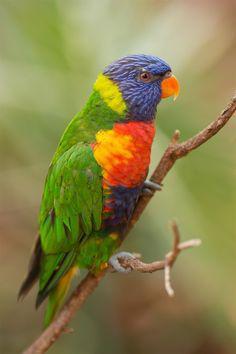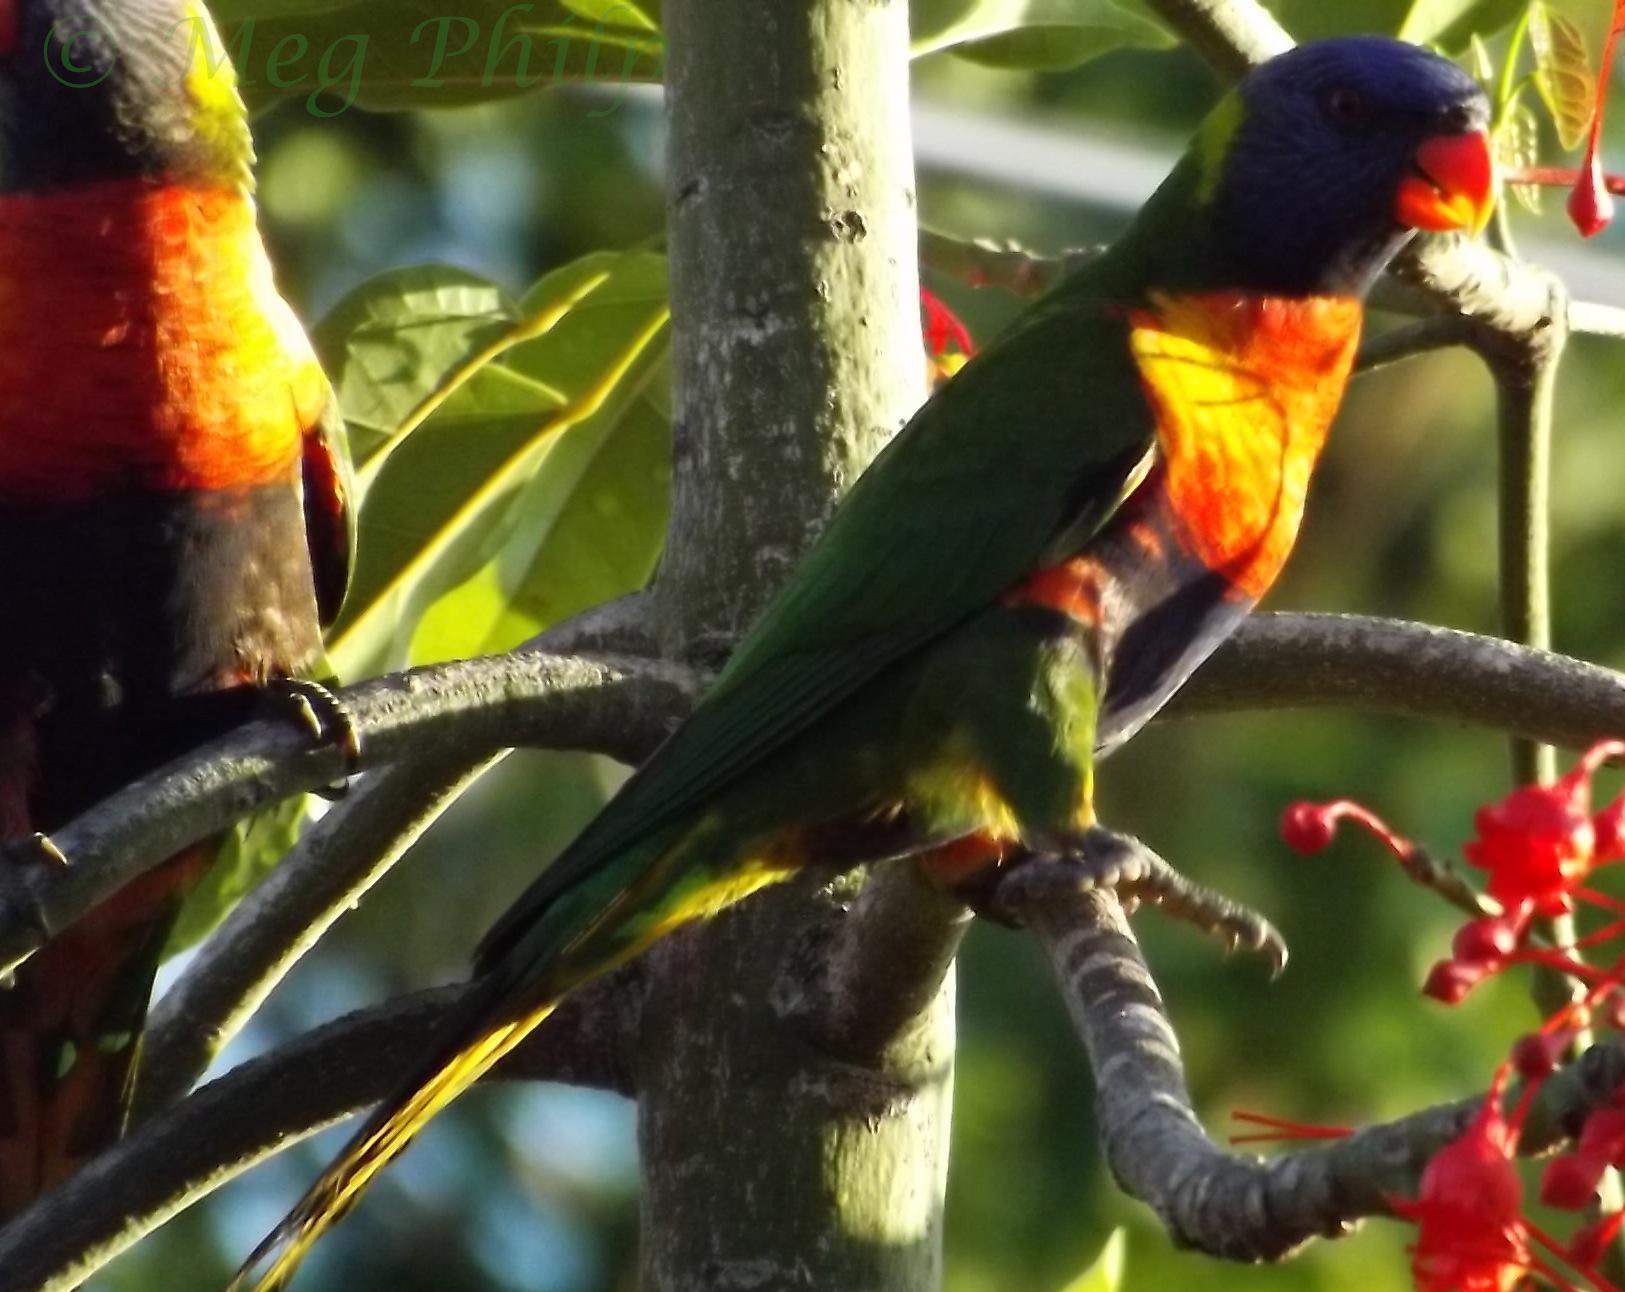The first image is the image on the left, the second image is the image on the right. Assess this claim about the two images: "At least one of the images shows three colourful parrots perched on a branch.". Correct or not? Answer yes or no. No. The first image is the image on the left, the second image is the image on the right. For the images displayed, is the sentence "At least two parrots are perched in branches containing bright red flower-like growths." factually correct? Answer yes or no. Yes. 